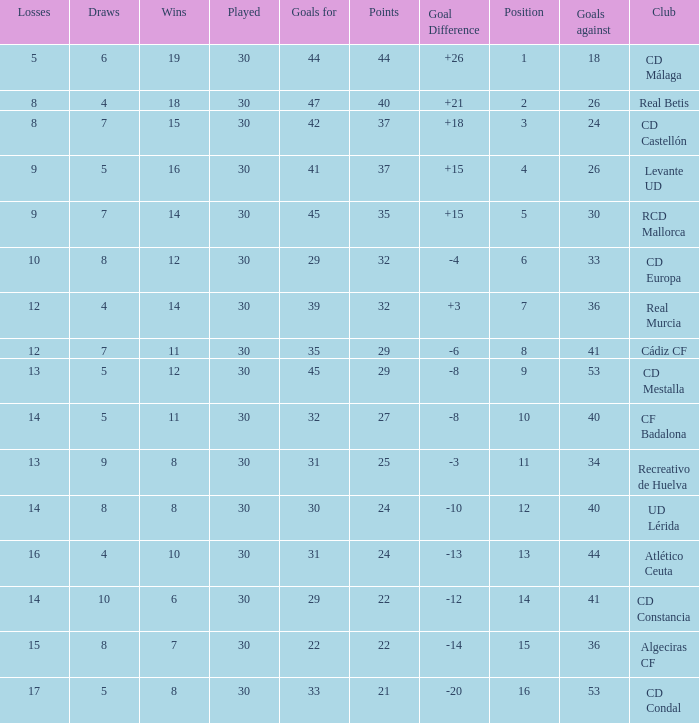What is the number of draws when played is smaller than 30? 0.0. 